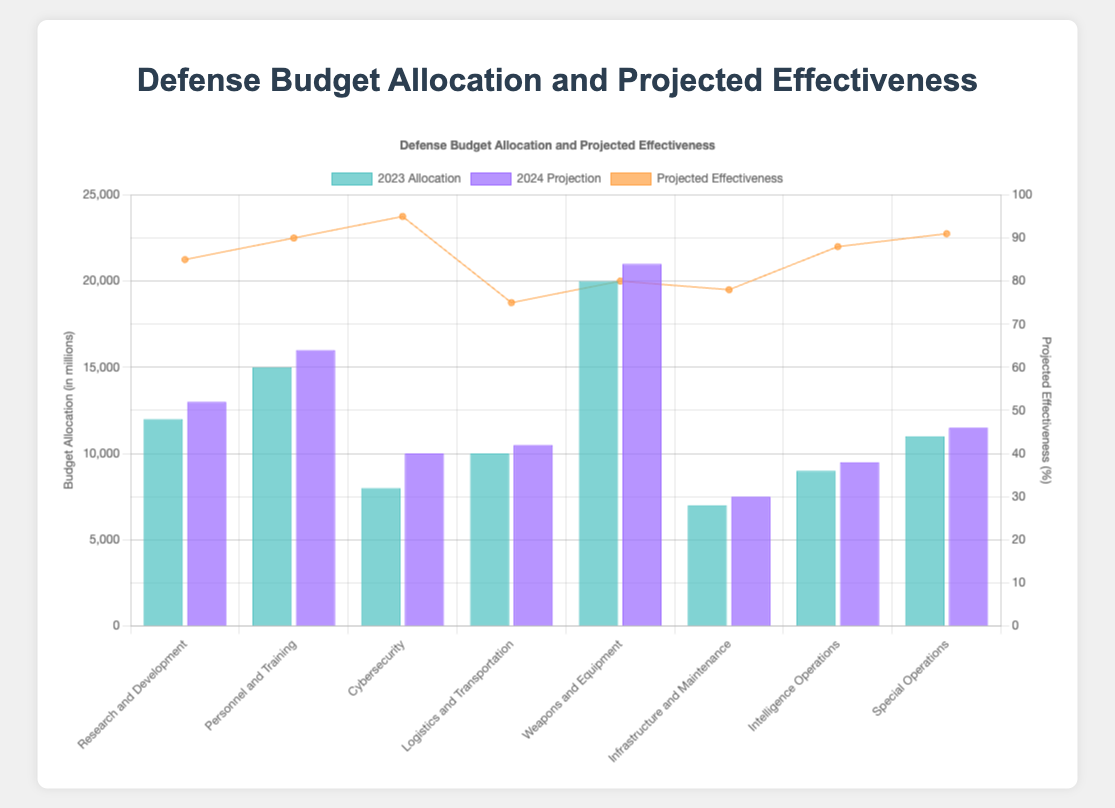Which sector has the highest budget allocation for 2023? The highest budget allocation for 2023 can be found by visually inspecting the heights of the bars for each sector in 2023 and locating the tallest bar. The tallest bar corresponds to the "Weapons and Equipment" sector.
Answer: Weapons and Equipment What is the total projected budget for 2024 for all sectors combined? To find the total projected budget for 2024, sum the projected allocations for each sector: 13000 (Research and Development) + 16000 (Personnel and Training) + 10000 (Cybersecurity) + 10500 (Logistics and Transportation) + 21000 (Weapons and Equipment) + 7500 (Infrastructure and Maintenance) + 9500 (Intelligence Operations) + 11500 (Special Operations) = 99000.
Answer: 99000 Which sector shows the highest projected effectiveness? To identify the sector with the highest projected effectiveness, compare the line graph points representing projected effectiveness for each sector. The highest point corresponds to "Cybersecurity" with a projected effectiveness of 95.
Answer: Cybersecurity How much more funding is projected for Cybersecurity in 2024 compared to its 2023 allocation? Subtract the 2023 allocation for Cybersecurity from its projected 2024 budget: 10000 (2024) - 8000 (2023) = 2000.
Answer: 2000 Which sector has the largest increase in budget allocation from 2023 to 2024? Calculate the increase for each sector by subtracting the 2023 allocation from the 2024 projection and identify the sector with the largest difference: Research and Development (13000 - 12000 = 1000), Personnel and Training (16000 - 15000 = 1000), Cybersecurity (10000 - 8000 = 2000), Logistics and Transportation (10500 - 10000 = 500), Weapons and Equipment (21000 - 20000 = 1000), Infrastructure and Maintenance (7500 - 7000 = 500), Intelligence Operations (9500 - 9000 = 500), Special Operations (11500 - 11000 = 500). Cybersecurity shows the largest increase of 2000.
Answer: Cybersecurity Which sector has a lower projected effectiveness than Logistics and Transportation? Compare the projected effectiveness values from the line graph. Logistics and Transportation has a projected effectiveness of 75. Sectors with lower values are: none since 75 is the lowest of all.
Answer: None What is the average projected effectiveness across all sectors? Sum the projected effectiveness values and divide by the number of sectors: (85 + 90 + 95 + 75 + 80 + 78 + 88 + 91) / 8 = 682 / 8 = 85.25.
Answer: 85.25 